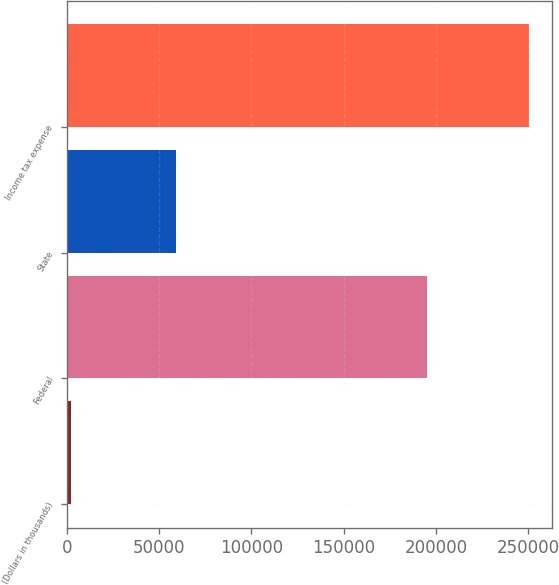Convert chart to OTSL. <chart><loc_0><loc_0><loc_500><loc_500><bar_chart><fcel>(Dollars in thousands)<fcel>Federal<fcel>State<fcel>Income tax expense<nl><fcel>2016<fcel>195249<fcel>59319<fcel>250333<nl></chart> 